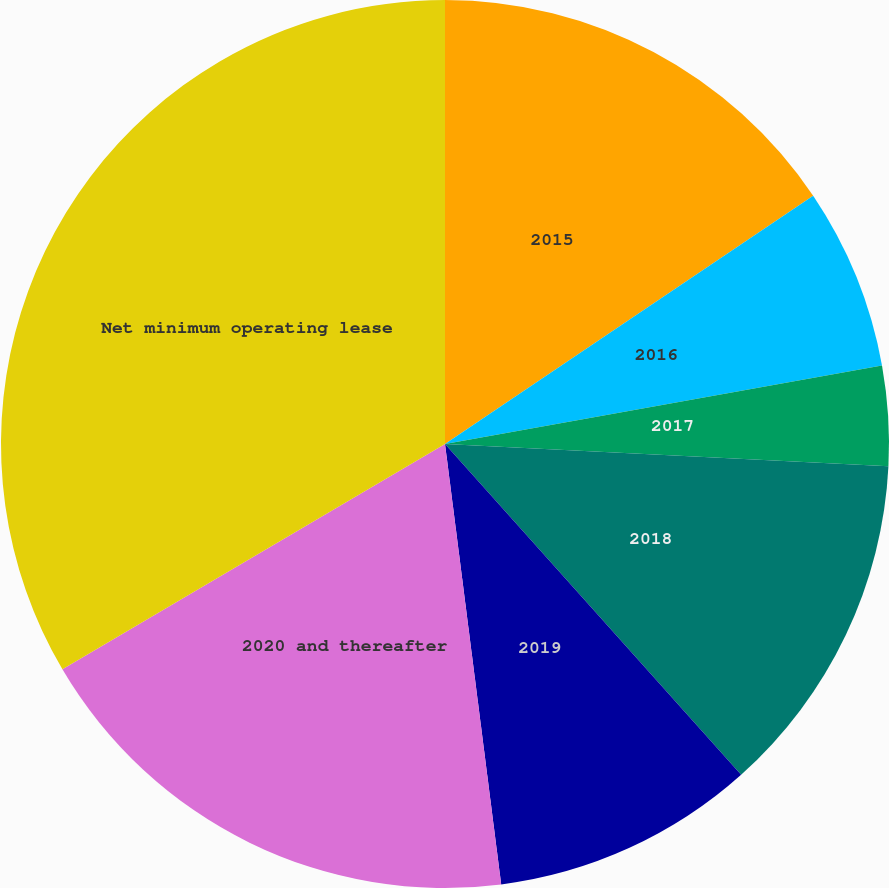<chart> <loc_0><loc_0><loc_500><loc_500><pie_chart><fcel>2015<fcel>2016<fcel>2017<fcel>2018<fcel>2019<fcel>2020 and thereafter<fcel>Net minimum operating lease<nl><fcel>15.56%<fcel>6.61%<fcel>3.63%<fcel>12.58%<fcel>9.6%<fcel>18.55%<fcel>33.47%<nl></chart> 